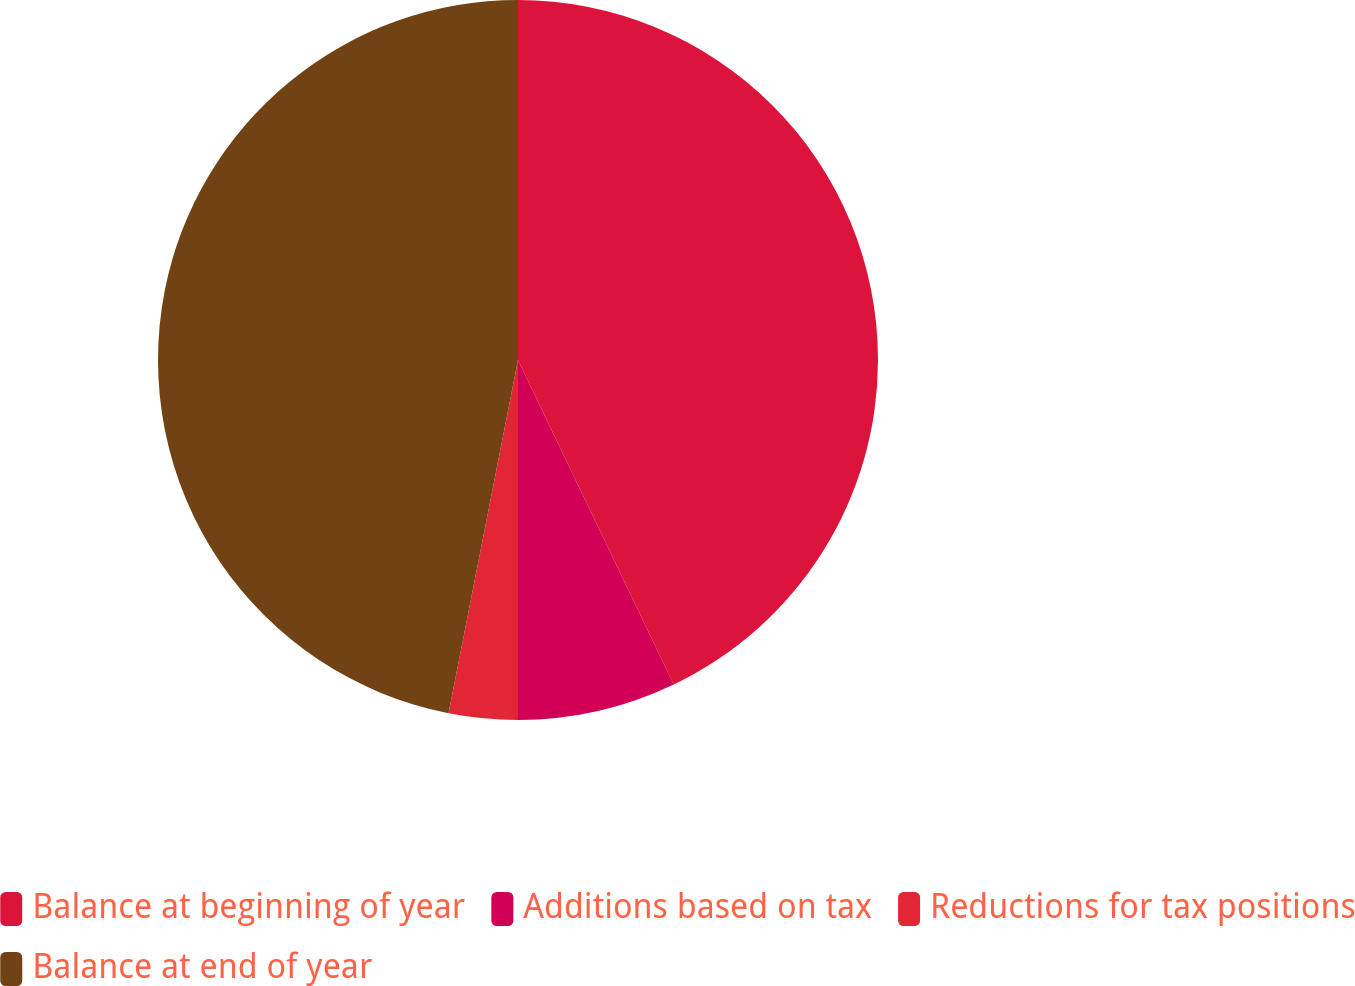Convert chart. <chart><loc_0><loc_0><loc_500><loc_500><pie_chart><fcel>Balance at beginning of year<fcel>Additions based on tax<fcel>Reductions for tax positions<fcel>Balance at end of year<nl><fcel>42.88%<fcel>7.12%<fcel>3.09%<fcel>46.91%<nl></chart> 